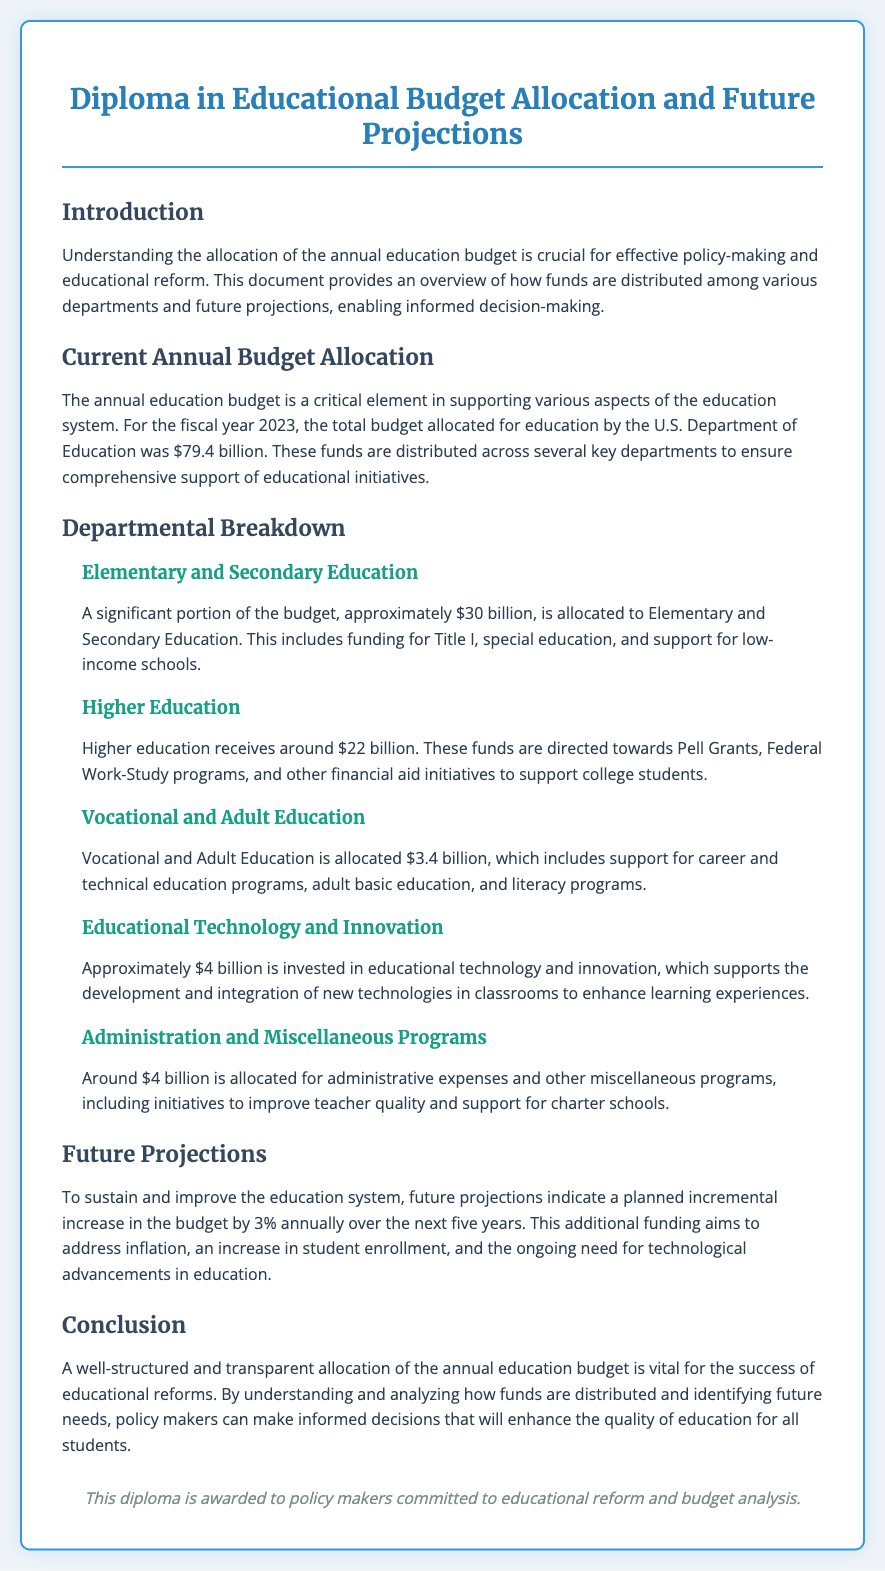What is the total education budget for 2023? The total education budget for 2023 is stated in the document as $79.4 billion.
Answer: $79.4 billion How much is allocated to Elementary and Secondary Education? The document specifies that approximately $30 billion is allocated to Elementary and Secondary Education.
Answer: $30 billion What is the planned annual budget increase percentage for the next five years? The document mentions a planned incremental increase in the budget by 3% annually over the next five years.
Answer: 3% What is the budget allocated for Higher Education? The document states that around $22 billion is allocated for Higher Education.
Answer: $22 billion What type of programs does the Vocational and Adult Education funding support? The document notes that Vocational and Adult Education funding supports career and technical education programs, adult basic education, and literacy programs.
Answer: Career and technical education programs, adult basic education, and literacy programs What is the total amount allocated for Educational Technology and Innovation? According to the document, approximately $4 billion is invested in educational technology and innovation.
Answer: $4 billion What does a well-structured education budget help achieve? The document concludes that a well-structured education budget is vital for the success of educational reforms.
Answer: Success of educational reforms Which department receives the smallest allocation among the listed ones? The document indicates that Vocational and Adult Education receives the smallest allocation of $3.4 billion.
Answer: Vocational and Adult Education 